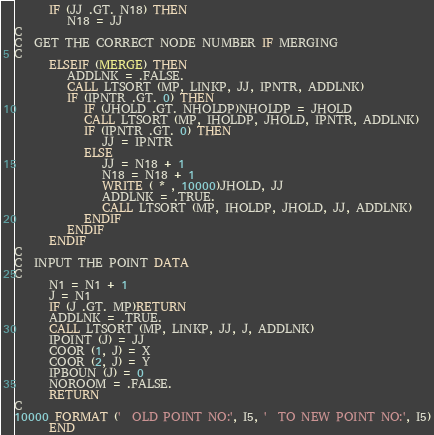<code> <loc_0><loc_0><loc_500><loc_500><_FORTRAN_>      IF (JJ .GT. N18) THEN
         N18 = JJ
C
C  GET THE CORRECT NODE NUMBER IF MERGING
C
      ELSEIF (MERGE) THEN
         ADDLNK = .FALSE.
         CALL LTSORT (MP, LINKP, JJ, IPNTR, ADDLNK)
         IF (IPNTR .GT. 0) THEN
            IF (JHOLD .GT. NHOLDP)NHOLDP = JHOLD
            CALL LTSORT (MP, IHOLDP, JHOLD, IPNTR, ADDLNK)
            IF (IPNTR .GT. 0) THEN
               JJ = IPNTR
            ELSE
               JJ = N18 + 1
               N18 = N18 + 1
               WRITE ( * , 10000)JHOLD, JJ
               ADDLNK = .TRUE.
               CALL LTSORT (MP, IHOLDP, JHOLD, JJ, ADDLNK)
            ENDIF
         ENDIF
      ENDIF
C
C  INPUT THE POINT DATA
C
      N1 = N1 + 1
      J = N1
      IF (J .GT. MP)RETURN
      ADDLNK = .TRUE.
      CALL LTSORT (MP, LINKP, JJ, J, ADDLNK)
      IPOINT (J) = JJ
      COOR (1, J) = X
      COOR (2, J) = Y
      IPBOUN (J) = 0
      NOROOM = .FALSE.
      RETURN
C
10000 FORMAT ('  OLD POINT NO:', I5, '  TO NEW POINT NO:', I5)
      END
</code> 